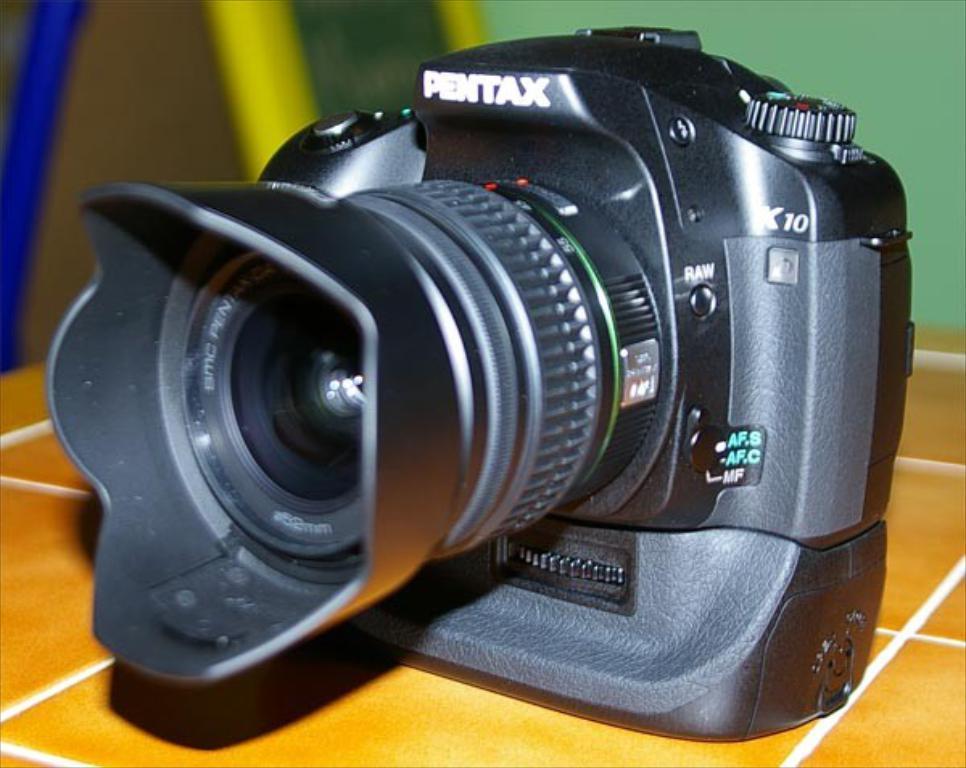How would you summarize this image in a sentence or two? In this image, we can see a camera with lens is placed on the tile surface. Background there is a blur view. 